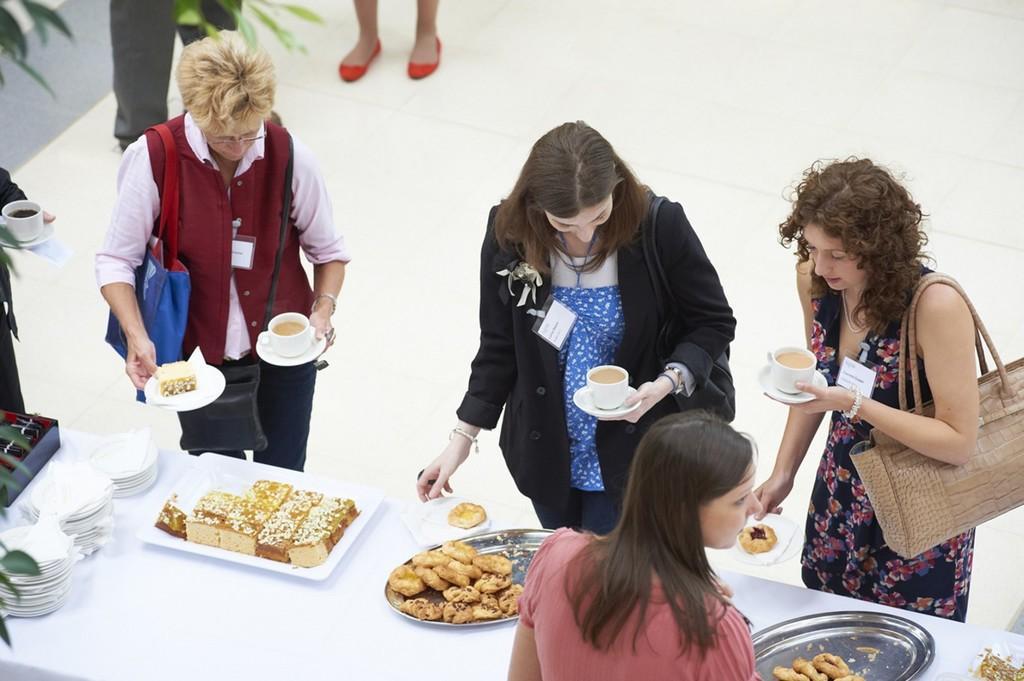Can you describe this image briefly? As we can see in the image there are few people here and there and there is a table. On table there are trays, plates and food items. 